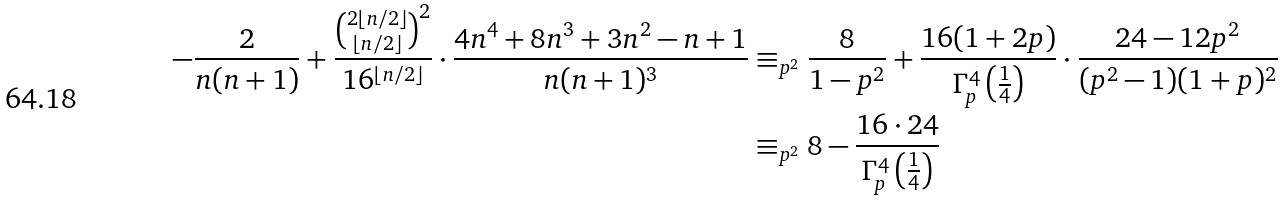<formula> <loc_0><loc_0><loc_500><loc_500>- \frac { 2 } { n ( n + 1 ) } + \frac { \binom { 2 \lfloor n / 2 \rfloor } { \lfloor n / 2 \rfloor } ^ { 2 } } { 1 6 ^ { \lfloor n / 2 \rfloor } } \cdot \frac { 4 n ^ { 4 } + 8 n ^ { 3 } + 3 n ^ { 2 } - n + 1 } { n ( n + 1 ) ^ { 3 } } & \equiv _ { p ^ { 2 } } \frac { 8 } { 1 - p ^ { 2 } } + \frac { 1 6 ( 1 + 2 p ) } { \Gamma ^ { 4 } _ { p } \left ( \frac { 1 } { 4 } \right ) } \cdot \frac { 2 4 - 1 2 p ^ { 2 } } { ( p ^ { 2 } - 1 ) ( 1 + p ) ^ { 2 } } \\ & \equiv _ { p ^ { 2 } } 8 - \frac { 1 6 \cdot 2 4 } { \Gamma ^ { 4 } _ { p } \left ( \frac { 1 } { 4 } \right ) }</formula> 